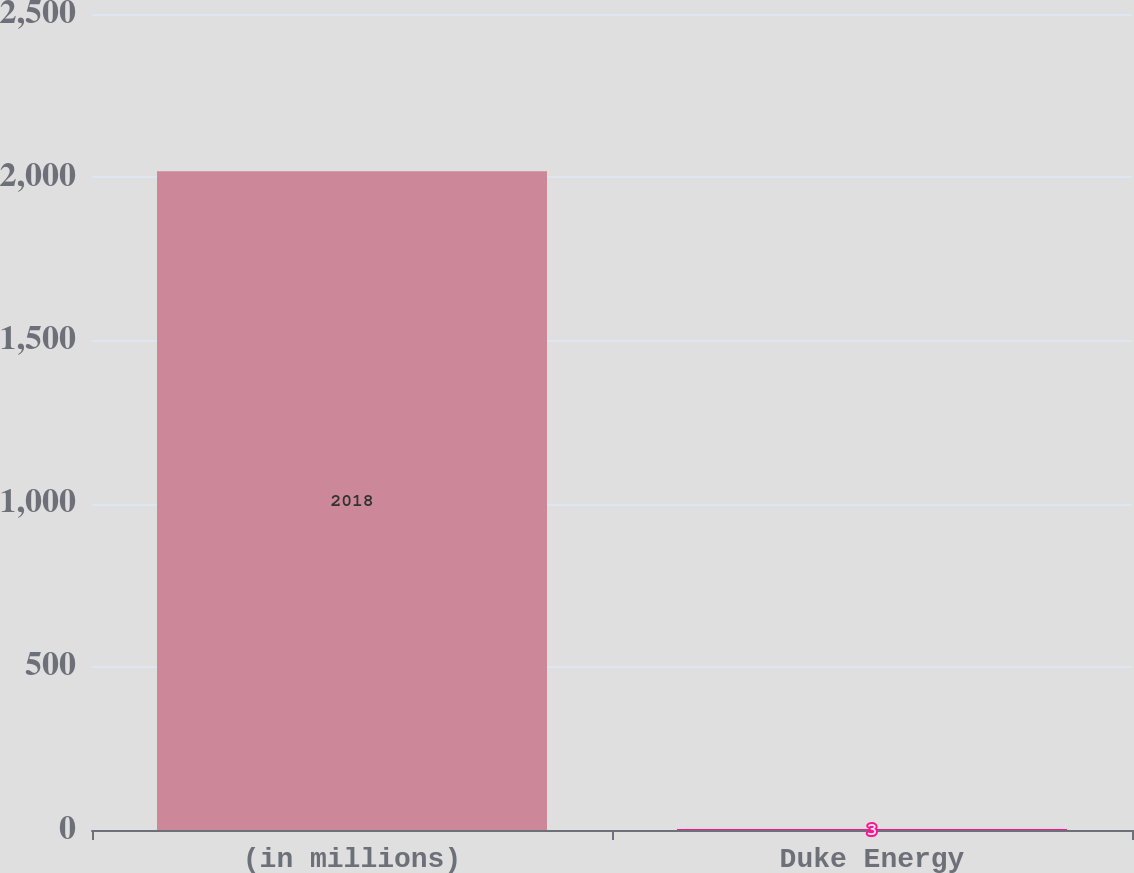Convert chart. <chart><loc_0><loc_0><loc_500><loc_500><bar_chart><fcel>(in millions)<fcel>Duke Energy<nl><fcel>2018<fcel>3<nl></chart> 